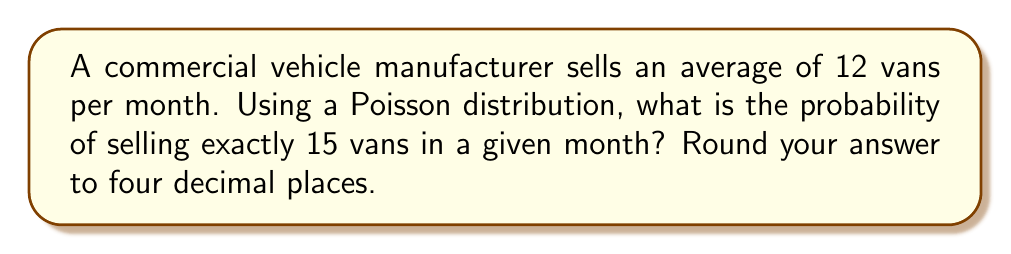Show me your answer to this math problem. To solve this problem, we'll use the Poisson distribution formula:

$$P(X = k) = \frac{e^{-\lambda} \lambda^k}{k!}$$

Where:
$\lambda$ = average number of events in the given time period
$k$ = number of events we're calculating the probability for
$e$ = Euler's number (approximately 2.71828)

Given:
$\lambda = 12$ (average of 12 vans sold per month)
$k = 15$ (we're calculating the probability of selling exactly 15 vans)

Step 1: Plug the values into the formula
$$P(X = 15) = \frac{e^{-12} 12^{15}}{15!}$$

Step 2: Calculate the numerator
$e^{-12} \approx 6.1442 \times 10^{-6}$
$12^{15} = 129,746,337,890,625$
Numerator $\approx 797.1639$

Step 3: Calculate the denominator
$15! = 1,307,674,368,000$

Step 4: Divide the numerator by the denominator
$$\frac{797.1639}{1,307,674,368,000} \approx 0.0000006097$$

Step 5: Round to four decimal places
$0.0000006097 \approx 0.0006$

Therefore, the probability of selling exactly 15 vans in a given month is approximately 0.0006 or 0.06%.
Answer: 0.0006 